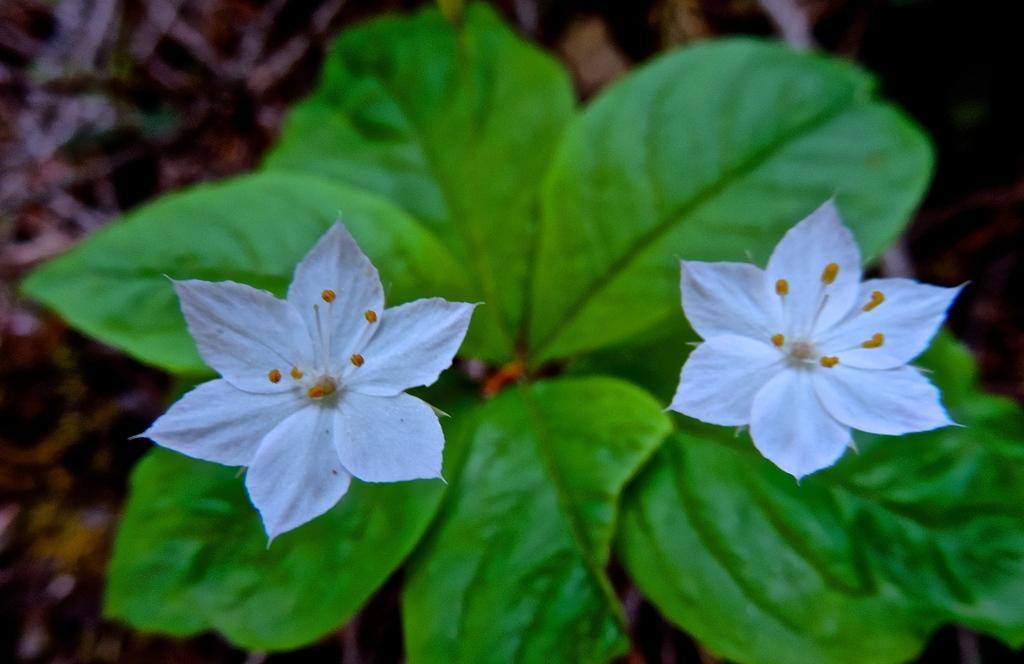In one or two sentences, can you explain what this image depicts? In this image, we can see flowers and leaves and the background is not clear. 